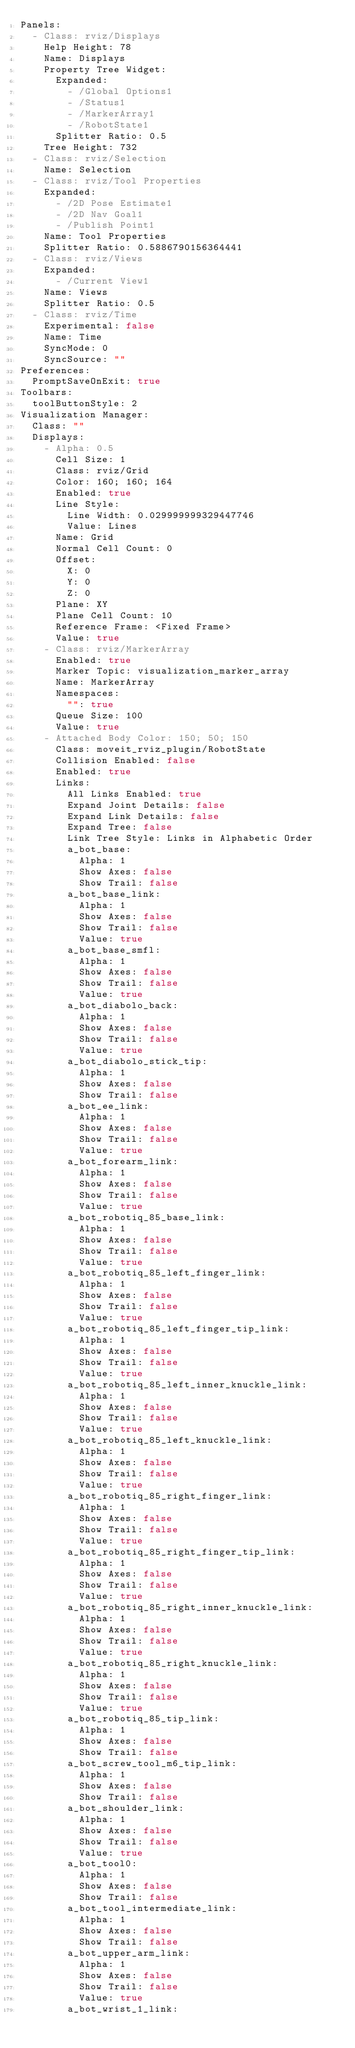Convert code to text. <code><loc_0><loc_0><loc_500><loc_500><_YAML_>Panels:
  - Class: rviz/Displays
    Help Height: 78
    Name: Displays
    Property Tree Widget:
      Expanded:
        - /Global Options1
        - /Status1
        - /MarkerArray1
        - /RobotState1
      Splitter Ratio: 0.5
    Tree Height: 732
  - Class: rviz/Selection
    Name: Selection
  - Class: rviz/Tool Properties
    Expanded:
      - /2D Pose Estimate1
      - /2D Nav Goal1
      - /Publish Point1
    Name: Tool Properties
    Splitter Ratio: 0.5886790156364441
  - Class: rviz/Views
    Expanded:
      - /Current View1
    Name: Views
    Splitter Ratio: 0.5
  - Class: rviz/Time
    Experimental: false
    Name: Time
    SyncMode: 0
    SyncSource: ""
Preferences:
  PromptSaveOnExit: true
Toolbars:
  toolButtonStyle: 2
Visualization Manager:
  Class: ""
  Displays:
    - Alpha: 0.5
      Cell Size: 1
      Class: rviz/Grid
      Color: 160; 160; 164
      Enabled: true
      Line Style:
        Line Width: 0.029999999329447746
        Value: Lines
      Name: Grid
      Normal Cell Count: 0
      Offset:
        X: 0
        Y: 0
        Z: 0
      Plane: XY
      Plane Cell Count: 10
      Reference Frame: <Fixed Frame>
      Value: true
    - Class: rviz/MarkerArray
      Enabled: true
      Marker Topic: visualization_marker_array
      Name: MarkerArray
      Namespaces:
        "": true
      Queue Size: 100
      Value: true
    - Attached Body Color: 150; 50; 150
      Class: moveit_rviz_plugin/RobotState
      Collision Enabled: false
      Enabled: true
      Links:
        All Links Enabled: true
        Expand Joint Details: false
        Expand Link Details: false
        Expand Tree: false
        Link Tree Style: Links in Alphabetic Order
        a_bot_base:
          Alpha: 1
          Show Axes: false
          Show Trail: false
        a_bot_base_link:
          Alpha: 1
          Show Axes: false
          Show Trail: false
          Value: true
        a_bot_base_smfl:
          Alpha: 1
          Show Axes: false
          Show Trail: false
          Value: true
        a_bot_diabolo_back:
          Alpha: 1
          Show Axes: false
          Show Trail: false
          Value: true
        a_bot_diabolo_stick_tip:
          Alpha: 1
          Show Axes: false
          Show Trail: false
        a_bot_ee_link:
          Alpha: 1
          Show Axes: false
          Show Trail: false
          Value: true
        a_bot_forearm_link:
          Alpha: 1
          Show Axes: false
          Show Trail: false
          Value: true
        a_bot_robotiq_85_base_link:
          Alpha: 1
          Show Axes: false
          Show Trail: false
          Value: true
        a_bot_robotiq_85_left_finger_link:
          Alpha: 1
          Show Axes: false
          Show Trail: false
          Value: true
        a_bot_robotiq_85_left_finger_tip_link:
          Alpha: 1
          Show Axes: false
          Show Trail: false
          Value: true
        a_bot_robotiq_85_left_inner_knuckle_link:
          Alpha: 1
          Show Axes: false
          Show Trail: false
          Value: true
        a_bot_robotiq_85_left_knuckle_link:
          Alpha: 1
          Show Axes: false
          Show Trail: false
          Value: true
        a_bot_robotiq_85_right_finger_link:
          Alpha: 1
          Show Axes: false
          Show Trail: false
          Value: true
        a_bot_robotiq_85_right_finger_tip_link:
          Alpha: 1
          Show Axes: false
          Show Trail: false
          Value: true
        a_bot_robotiq_85_right_inner_knuckle_link:
          Alpha: 1
          Show Axes: false
          Show Trail: false
          Value: true
        a_bot_robotiq_85_right_knuckle_link:
          Alpha: 1
          Show Axes: false
          Show Trail: false
          Value: true
        a_bot_robotiq_85_tip_link:
          Alpha: 1
          Show Axes: false
          Show Trail: false
        a_bot_screw_tool_m6_tip_link:
          Alpha: 1
          Show Axes: false
          Show Trail: false
        a_bot_shoulder_link:
          Alpha: 1
          Show Axes: false
          Show Trail: false
          Value: true
        a_bot_tool0:
          Alpha: 1
          Show Axes: false
          Show Trail: false
        a_bot_tool_intermediate_link:
          Alpha: 1
          Show Axes: false
          Show Trail: false
        a_bot_upper_arm_link:
          Alpha: 1
          Show Axes: false
          Show Trail: false
          Value: true
        a_bot_wrist_1_link:</code> 